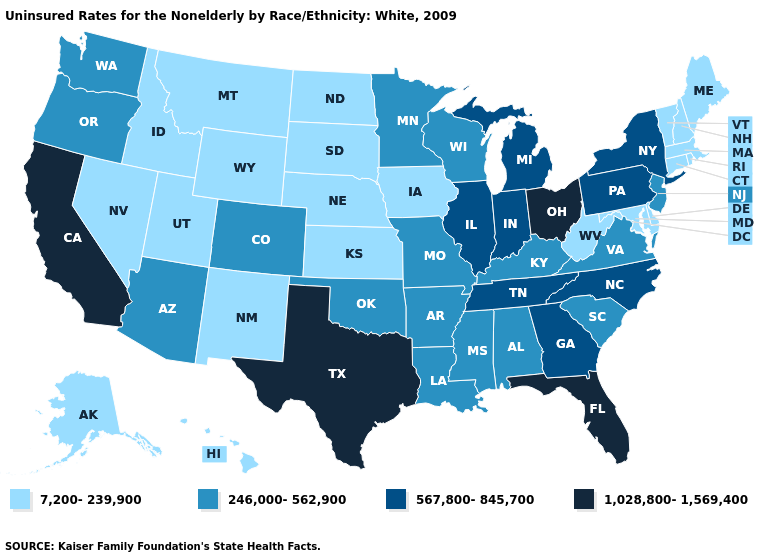Name the states that have a value in the range 567,800-845,700?
Answer briefly. Georgia, Illinois, Indiana, Michigan, New York, North Carolina, Pennsylvania, Tennessee. What is the value of Texas?
Be succinct. 1,028,800-1,569,400. Which states have the highest value in the USA?
Short answer required. California, Florida, Ohio, Texas. What is the lowest value in the MidWest?
Write a very short answer. 7,200-239,900. Which states have the lowest value in the USA?
Be succinct. Alaska, Connecticut, Delaware, Hawaii, Idaho, Iowa, Kansas, Maine, Maryland, Massachusetts, Montana, Nebraska, Nevada, New Hampshire, New Mexico, North Dakota, Rhode Island, South Dakota, Utah, Vermont, West Virginia, Wyoming. Does Missouri have a higher value than South Dakota?
Short answer required. Yes. Name the states that have a value in the range 7,200-239,900?
Short answer required. Alaska, Connecticut, Delaware, Hawaii, Idaho, Iowa, Kansas, Maine, Maryland, Massachusetts, Montana, Nebraska, Nevada, New Hampshire, New Mexico, North Dakota, Rhode Island, South Dakota, Utah, Vermont, West Virginia, Wyoming. What is the value of Minnesota?
Quick response, please. 246,000-562,900. What is the highest value in the Northeast ?
Be succinct. 567,800-845,700. Name the states that have a value in the range 246,000-562,900?
Short answer required. Alabama, Arizona, Arkansas, Colorado, Kentucky, Louisiana, Minnesota, Mississippi, Missouri, New Jersey, Oklahoma, Oregon, South Carolina, Virginia, Washington, Wisconsin. Name the states that have a value in the range 567,800-845,700?
Be succinct. Georgia, Illinois, Indiana, Michigan, New York, North Carolina, Pennsylvania, Tennessee. Name the states that have a value in the range 7,200-239,900?
Write a very short answer. Alaska, Connecticut, Delaware, Hawaii, Idaho, Iowa, Kansas, Maine, Maryland, Massachusetts, Montana, Nebraska, Nevada, New Hampshire, New Mexico, North Dakota, Rhode Island, South Dakota, Utah, Vermont, West Virginia, Wyoming. How many symbols are there in the legend?
Answer briefly. 4. Does California have the highest value in the West?
Keep it brief. Yes. 